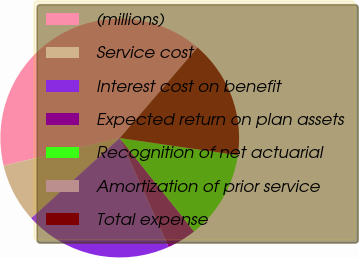<chart> <loc_0><loc_0><loc_500><loc_500><pie_chart><fcel>(millions)<fcel>Service cost<fcel>Interest cost on benefit<fcel>Expected return on plan assets<fcel>Recognition of net actuarial<fcel>Amortization of prior service<fcel>Total expense<nl><fcel>40.0%<fcel>8.0%<fcel>20.0%<fcel>4.0%<fcel>12.0%<fcel>0.0%<fcel>16.0%<nl></chart> 